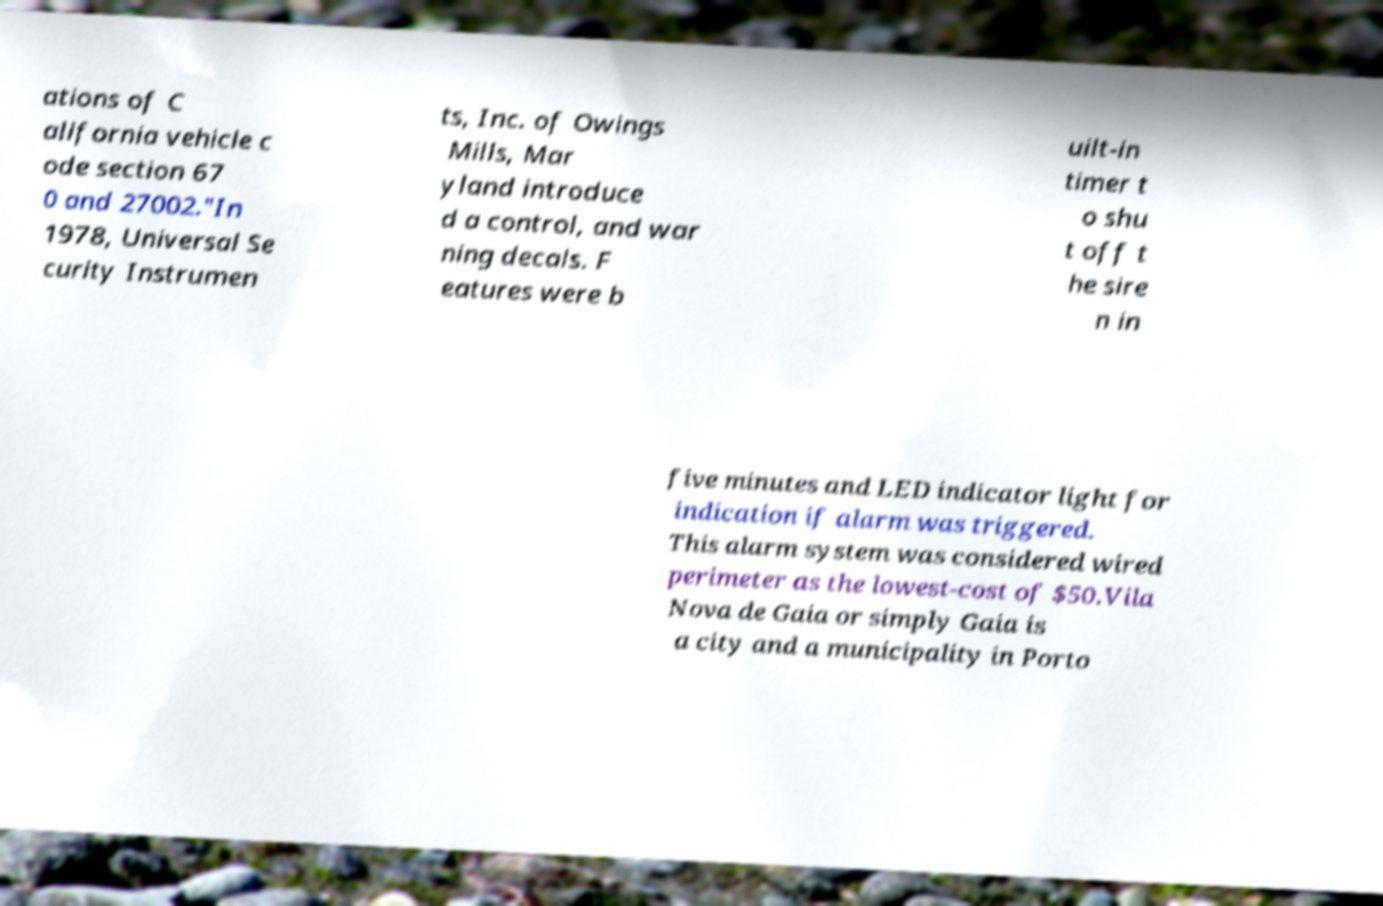Please identify and transcribe the text found in this image. ations of C alifornia vehicle c ode section 67 0 and 27002."In 1978, Universal Se curity Instrumen ts, Inc. of Owings Mills, Mar yland introduce d a control, and war ning decals. F eatures were b uilt-in timer t o shu t off t he sire n in five minutes and LED indicator light for indication if alarm was triggered. This alarm system was considered wired perimeter as the lowest-cost of $50.Vila Nova de Gaia or simply Gaia is a city and a municipality in Porto 